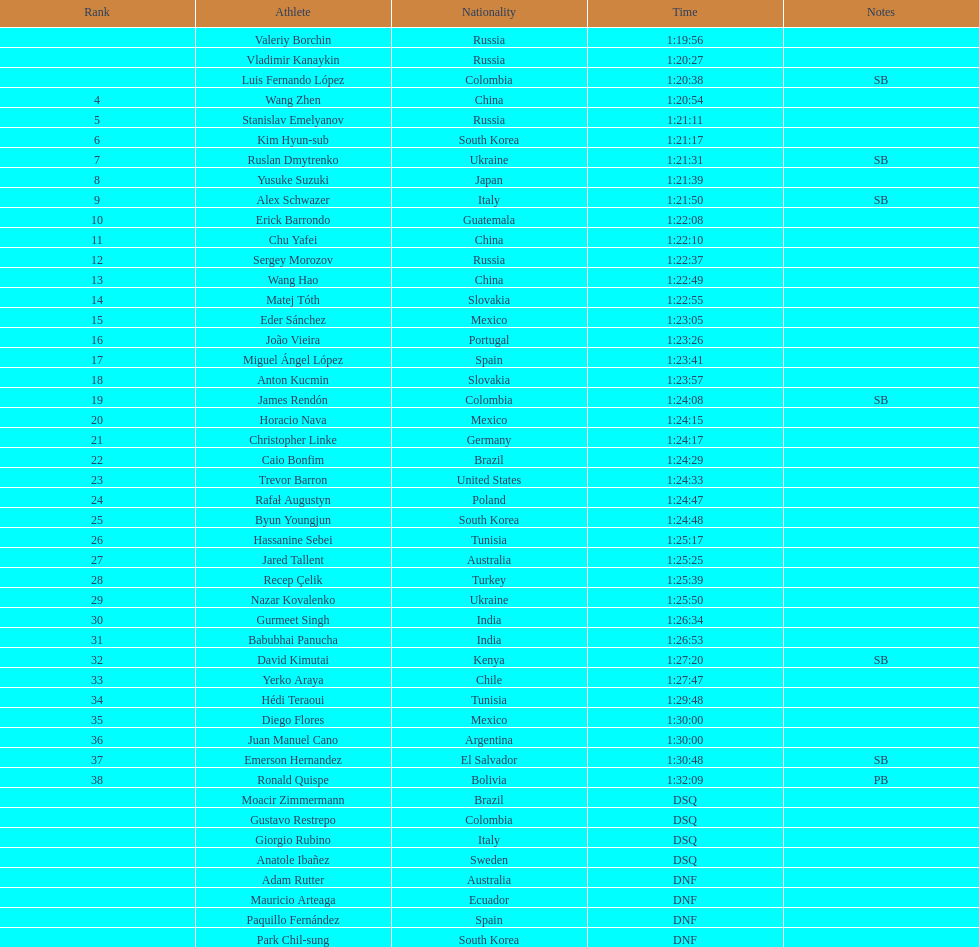Which chinese athlete had the fastest time? Wang Zhen. 